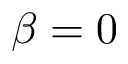Convert formula to latex. <formula><loc_0><loc_0><loc_500><loc_500>\beta = 0</formula> 